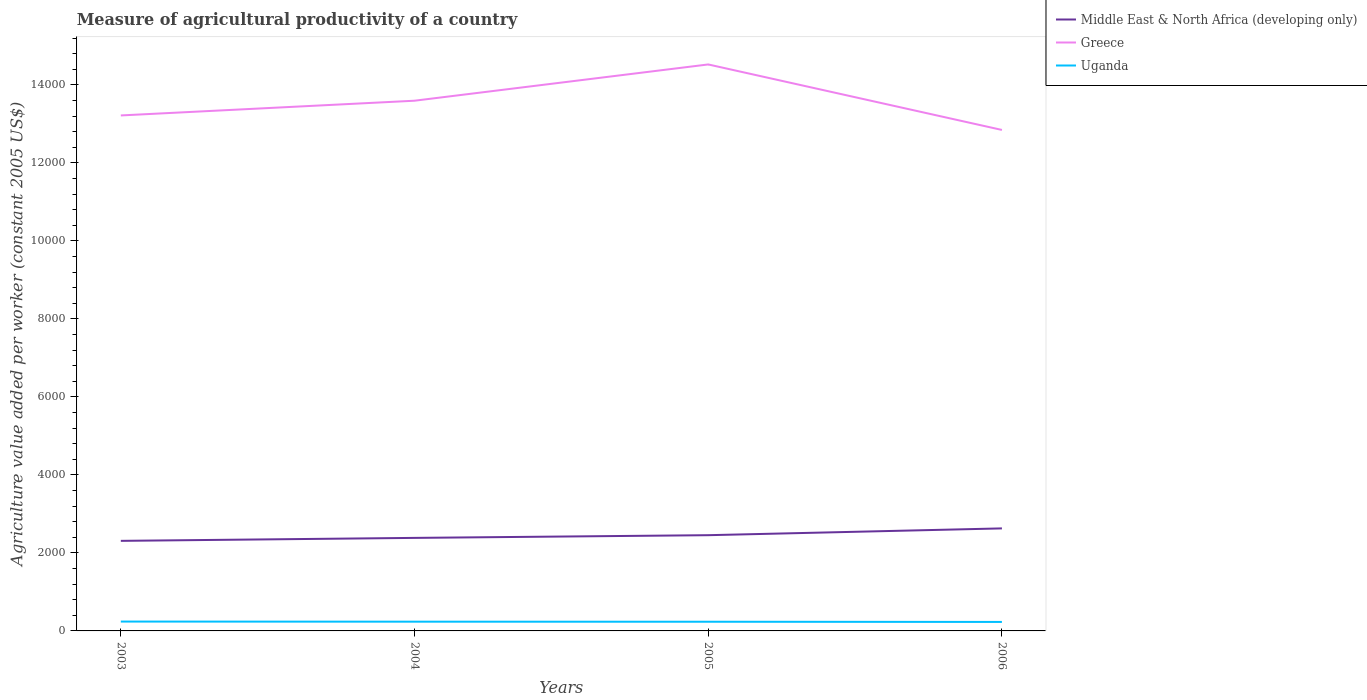Is the number of lines equal to the number of legend labels?
Keep it short and to the point. Yes. Across all years, what is the maximum measure of agricultural productivity in Uganda?
Ensure brevity in your answer.  230.42. What is the total measure of agricultural productivity in Uganda in the graph?
Provide a short and direct response. 1.57. What is the difference between the highest and the second highest measure of agricultural productivity in Uganda?
Keep it short and to the point. 9.42. How many lines are there?
Provide a short and direct response. 3. How many years are there in the graph?
Your answer should be very brief. 4. Are the values on the major ticks of Y-axis written in scientific E-notation?
Keep it short and to the point. No. Does the graph contain any zero values?
Provide a short and direct response. No. Does the graph contain grids?
Your response must be concise. No. Where does the legend appear in the graph?
Keep it short and to the point. Top right. What is the title of the graph?
Offer a very short reply. Measure of agricultural productivity of a country. Does "Italy" appear as one of the legend labels in the graph?
Ensure brevity in your answer.  No. What is the label or title of the Y-axis?
Your answer should be compact. Agriculture value added per worker (constant 2005 US$). What is the Agriculture value added per worker (constant 2005 US$) in Middle East & North Africa (developing only) in 2003?
Provide a succinct answer. 2308.81. What is the Agriculture value added per worker (constant 2005 US$) of Greece in 2003?
Provide a short and direct response. 1.32e+04. What is the Agriculture value added per worker (constant 2005 US$) in Uganda in 2003?
Make the answer very short. 239.84. What is the Agriculture value added per worker (constant 2005 US$) of Middle East & North Africa (developing only) in 2004?
Offer a terse response. 2384.77. What is the Agriculture value added per worker (constant 2005 US$) in Greece in 2004?
Make the answer very short. 1.36e+04. What is the Agriculture value added per worker (constant 2005 US$) of Uganda in 2004?
Ensure brevity in your answer.  237.21. What is the Agriculture value added per worker (constant 2005 US$) in Middle East & North Africa (developing only) in 2005?
Your response must be concise. 2454.17. What is the Agriculture value added per worker (constant 2005 US$) of Greece in 2005?
Provide a short and direct response. 1.45e+04. What is the Agriculture value added per worker (constant 2005 US$) in Uganda in 2005?
Provide a short and direct response. 235.64. What is the Agriculture value added per worker (constant 2005 US$) of Middle East & North Africa (developing only) in 2006?
Ensure brevity in your answer.  2628.31. What is the Agriculture value added per worker (constant 2005 US$) of Greece in 2006?
Offer a terse response. 1.28e+04. What is the Agriculture value added per worker (constant 2005 US$) in Uganda in 2006?
Offer a very short reply. 230.42. Across all years, what is the maximum Agriculture value added per worker (constant 2005 US$) in Middle East & North Africa (developing only)?
Make the answer very short. 2628.31. Across all years, what is the maximum Agriculture value added per worker (constant 2005 US$) of Greece?
Make the answer very short. 1.45e+04. Across all years, what is the maximum Agriculture value added per worker (constant 2005 US$) in Uganda?
Your answer should be very brief. 239.84. Across all years, what is the minimum Agriculture value added per worker (constant 2005 US$) of Middle East & North Africa (developing only)?
Keep it short and to the point. 2308.81. Across all years, what is the minimum Agriculture value added per worker (constant 2005 US$) in Greece?
Your answer should be very brief. 1.28e+04. Across all years, what is the minimum Agriculture value added per worker (constant 2005 US$) in Uganda?
Offer a terse response. 230.42. What is the total Agriculture value added per worker (constant 2005 US$) in Middle East & North Africa (developing only) in the graph?
Keep it short and to the point. 9776.05. What is the total Agriculture value added per worker (constant 2005 US$) in Greece in the graph?
Give a very brief answer. 5.42e+04. What is the total Agriculture value added per worker (constant 2005 US$) of Uganda in the graph?
Keep it short and to the point. 943.11. What is the difference between the Agriculture value added per worker (constant 2005 US$) of Middle East & North Africa (developing only) in 2003 and that in 2004?
Offer a terse response. -75.96. What is the difference between the Agriculture value added per worker (constant 2005 US$) in Greece in 2003 and that in 2004?
Your answer should be compact. -377.48. What is the difference between the Agriculture value added per worker (constant 2005 US$) in Uganda in 2003 and that in 2004?
Offer a very short reply. 2.64. What is the difference between the Agriculture value added per worker (constant 2005 US$) of Middle East & North Africa (developing only) in 2003 and that in 2005?
Your answer should be very brief. -145.36. What is the difference between the Agriculture value added per worker (constant 2005 US$) in Greece in 2003 and that in 2005?
Ensure brevity in your answer.  -1307.27. What is the difference between the Agriculture value added per worker (constant 2005 US$) in Uganda in 2003 and that in 2005?
Ensure brevity in your answer.  4.21. What is the difference between the Agriculture value added per worker (constant 2005 US$) in Middle East & North Africa (developing only) in 2003 and that in 2006?
Your answer should be compact. -319.51. What is the difference between the Agriculture value added per worker (constant 2005 US$) of Greece in 2003 and that in 2006?
Your answer should be very brief. 371.91. What is the difference between the Agriculture value added per worker (constant 2005 US$) in Uganda in 2003 and that in 2006?
Make the answer very short. 9.42. What is the difference between the Agriculture value added per worker (constant 2005 US$) in Middle East & North Africa (developing only) in 2004 and that in 2005?
Offer a terse response. -69.4. What is the difference between the Agriculture value added per worker (constant 2005 US$) in Greece in 2004 and that in 2005?
Your response must be concise. -929.79. What is the difference between the Agriculture value added per worker (constant 2005 US$) of Uganda in 2004 and that in 2005?
Your response must be concise. 1.57. What is the difference between the Agriculture value added per worker (constant 2005 US$) of Middle East & North Africa (developing only) in 2004 and that in 2006?
Offer a terse response. -243.55. What is the difference between the Agriculture value added per worker (constant 2005 US$) of Greece in 2004 and that in 2006?
Give a very brief answer. 749.4. What is the difference between the Agriculture value added per worker (constant 2005 US$) of Uganda in 2004 and that in 2006?
Keep it short and to the point. 6.79. What is the difference between the Agriculture value added per worker (constant 2005 US$) in Middle East & North Africa (developing only) in 2005 and that in 2006?
Provide a succinct answer. -174.15. What is the difference between the Agriculture value added per worker (constant 2005 US$) in Greece in 2005 and that in 2006?
Make the answer very short. 1679.19. What is the difference between the Agriculture value added per worker (constant 2005 US$) of Uganda in 2005 and that in 2006?
Your answer should be very brief. 5.21. What is the difference between the Agriculture value added per worker (constant 2005 US$) of Middle East & North Africa (developing only) in 2003 and the Agriculture value added per worker (constant 2005 US$) of Greece in 2004?
Your answer should be compact. -1.13e+04. What is the difference between the Agriculture value added per worker (constant 2005 US$) in Middle East & North Africa (developing only) in 2003 and the Agriculture value added per worker (constant 2005 US$) in Uganda in 2004?
Your answer should be compact. 2071.6. What is the difference between the Agriculture value added per worker (constant 2005 US$) in Greece in 2003 and the Agriculture value added per worker (constant 2005 US$) in Uganda in 2004?
Your answer should be very brief. 1.30e+04. What is the difference between the Agriculture value added per worker (constant 2005 US$) in Middle East & North Africa (developing only) in 2003 and the Agriculture value added per worker (constant 2005 US$) in Greece in 2005?
Give a very brief answer. -1.22e+04. What is the difference between the Agriculture value added per worker (constant 2005 US$) in Middle East & North Africa (developing only) in 2003 and the Agriculture value added per worker (constant 2005 US$) in Uganda in 2005?
Give a very brief answer. 2073.17. What is the difference between the Agriculture value added per worker (constant 2005 US$) of Greece in 2003 and the Agriculture value added per worker (constant 2005 US$) of Uganda in 2005?
Your response must be concise. 1.30e+04. What is the difference between the Agriculture value added per worker (constant 2005 US$) of Middle East & North Africa (developing only) in 2003 and the Agriculture value added per worker (constant 2005 US$) of Greece in 2006?
Offer a very short reply. -1.05e+04. What is the difference between the Agriculture value added per worker (constant 2005 US$) in Middle East & North Africa (developing only) in 2003 and the Agriculture value added per worker (constant 2005 US$) in Uganda in 2006?
Your response must be concise. 2078.38. What is the difference between the Agriculture value added per worker (constant 2005 US$) in Greece in 2003 and the Agriculture value added per worker (constant 2005 US$) in Uganda in 2006?
Your response must be concise. 1.30e+04. What is the difference between the Agriculture value added per worker (constant 2005 US$) of Middle East & North Africa (developing only) in 2004 and the Agriculture value added per worker (constant 2005 US$) of Greece in 2005?
Provide a short and direct response. -1.21e+04. What is the difference between the Agriculture value added per worker (constant 2005 US$) in Middle East & North Africa (developing only) in 2004 and the Agriculture value added per worker (constant 2005 US$) in Uganda in 2005?
Offer a terse response. 2149.13. What is the difference between the Agriculture value added per worker (constant 2005 US$) in Greece in 2004 and the Agriculture value added per worker (constant 2005 US$) in Uganda in 2005?
Your answer should be compact. 1.34e+04. What is the difference between the Agriculture value added per worker (constant 2005 US$) in Middle East & North Africa (developing only) in 2004 and the Agriculture value added per worker (constant 2005 US$) in Greece in 2006?
Keep it short and to the point. -1.05e+04. What is the difference between the Agriculture value added per worker (constant 2005 US$) of Middle East & North Africa (developing only) in 2004 and the Agriculture value added per worker (constant 2005 US$) of Uganda in 2006?
Give a very brief answer. 2154.34. What is the difference between the Agriculture value added per worker (constant 2005 US$) of Greece in 2004 and the Agriculture value added per worker (constant 2005 US$) of Uganda in 2006?
Your answer should be very brief. 1.34e+04. What is the difference between the Agriculture value added per worker (constant 2005 US$) of Middle East & North Africa (developing only) in 2005 and the Agriculture value added per worker (constant 2005 US$) of Greece in 2006?
Your response must be concise. -1.04e+04. What is the difference between the Agriculture value added per worker (constant 2005 US$) in Middle East & North Africa (developing only) in 2005 and the Agriculture value added per worker (constant 2005 US$) in Uganda in 2006?
Ensure brevity in your answer.  2223.74. What is the difference between the Agriculture value added per worker (constant 2005 US$) of Greece in 2005 and the Agriculture value added per worker (constant 2005 US$) of Uganda in 2006?
Provide a short and direct response. 1.43e+04. What is the average Agriculture value added per worker (constant 2005 US$) in Middle East & North Africa (developing only) per year?
Offer a terse response. 2444.01. What is the average Agriculture value added per worker (constant 2005 US$) of Greece per year?
Provide a succinct answer. 1.35e+04. What is the average Agriculture value added per worker (constant 2005 US$) of Uganda per year?
Keep it short and to the point. 235.78. In the year 2003, what is the difference between the Agriculture value added per worker (constant 2005 US$) of Middle East & North Africa (developing only) and Agriculture value added per worker (constant 2005 US$) of Greece?
Ensure brevity in your answer.  -1.09e+04. In the year 2003, what is the difference between the Agriculture value added per worker (constant 2005 US$) of Middle East & North Africa (developing only) and Agriculture value added per worker (constant 2005 US$) of Uganda?
Keep it short and to the point. 2068.96. In the year 2003, what is the difference between the Agriculture value added per worker (constant 2005 US$) in Greece and Agriculture value added per worker (constant 2005 US$) in Uganda?
Your answer should be compact. 1.30e+04. In the year 2004, what is the difference between the Agriculture value added per worker (constant 2005 US$) in Middle East & North Africa (developing only) and Agriculture value added per worker (constant 2005 US$) in Greece?
Make the answer very short. -1.12e+04. In the year 2004, what is the difference between the Agriculture value added per worker (constant 2005 US$) of Middle East & North Africa (developing only) and Agriculture value added per worker (constant 2005 US$) of Uganda?
Your answer should be very brief. 2147.56. In the year 2004, what is the difference between the Agriculture value added per worker (constant 2005 US$) of Greece and Agriculture value added per worker (constant 2005 US$) of Uganda?
Your response must be concise. 1.34e+04. In the year 2005, what is the difference between the Agriculture value added per worker (constant 2005 US$) in Middle East & North Africa (developing only) and Agriculture value added per worker (constant 2005 US$) in Greece?
Ensure brevity in your answer.  -1.21e+04. In the year 2005, what is the difference between the Agriculture value added per worker (constant 2005 US$) of Middle East & North Africa (developing only) and Agriculture value added per worker (constant 2005 US$) of Uganda?
Your response must be concise. 2218.53. In the year 2005, what is the difference between the Agriculture value added per worker (constant 2005 US$) of Greece and Agriculture value added per worker (constant 2005 US$) of Uganda?
Offer a very short reply. 1.43e+04. In the year 2006, what is the difference between the Agriculture value added per worker (constant 2005 US$) of Middle East & North Africa (developing only) and Agriculture value added per worker (constant 2005 US$) of Greece?
Your response must be concise. -1.02e+04. In the year 2006, what is the difference between the Agriculture value added per worker (constant 2005 US$) in Middle East & North Africa (developing only) and Agriculture value added per worker (constant 2005 US$) in Uganda?
Provide a succinct answer. 2397.89. In the year 2006, what is the difference between the Agriculture value added per worker (constant 2005 US$) in Greece and Agriculture value added per worker (constant 2005 US$) in Uganda?
Give a very brief answer. 1.26e+04. What is the ratio of the Agriculture value added per worker (constant 2005 US$) in Middle East & North Africa (developing only) in 2003 to that in 2004?
Your answer should be very brief. 0.97. What is the ratio of the Agriculture value added per worker (constant 2005 US$) in Greece in 2003 to that in 2004?
Offer a terse response. 0.97. What is the ratio of the Agriculture value added per worker (constant 2005 US$) in Uganda in 2003 to that in 2004?
Provide a succinct answer. 1.01. What is the ratio of the Agriculture value added per worker (constant 2005 US$) of Middle East & North Africa (developing only) in 2003 to that in 2005?
Keep it short and to the point. 0.94. What is the ratio of the Agriculture value added per worker (constant 2005 US$) in Greece in 2003 to that in 2005?
Ensure brevity in your answer.  0.91. What is the ratio of the Agriculture value added per worker (constant 2005 US$) in Uganda in 2003 to that in 2005?
Make the answer very short. 1.02. What is the ratio of the Agriculture value added per worker (constant 2005 US$) of Middle East & North Africa (developing only) in 2003 to that in 2006?
Your answer should be very brief. 0.88. What is the ratio of the Agriculture value added per worker (constant 2005 US$) in Uganda in 2003 to that in 2006?
Keep it short and to the point. 1.04. What is the ratio of the Agriculture value added per worker (constant 2005 US$) in Middle East & North Africa (developing only) in 2004 to that in 2005?
Offer a terse response. 0.97. What is the ratio of the Agriculture value added per worker (constant 2005 US$) in Greece in 2004 to that in 2005?
Give a very brief answer. 0.94. What is the ratio of the Agriculture value added per worker (constant 2005 US$) of Middle East & North Africa (developing only) in 2004 to that in 2006?
Ensure brevity in your answer.  0.91. What is the ratio of the Agriculture value added per worker (constant 2005 US$) in Greece in 2004 to that in 2006?
Your answer should be compact. 1.06. What is the ratio of the Agriculture value added per worker (constant 2005 US$) in Uganda in 2004 to that in 2006?
Make the answer very short. 1.03. What is the ratio of the Agriculture value added per worker (constant 2005 US$) of Middle East & North Africa (developing only) in 2005 to that in 2006?
Your answer should be compact. 0.93. What is the ratio of the Agriculture value added per worker (constant 2005 US$) of Greece in 2005 to that in 2006?
Your response must be concise. 1.13. What is the ratio of the Agriculture value added per worker (constant 2005 US$) of Uganda in 2005 to that in 2006?
Keep it short and to the point. 1.02. What is the difference between the highest and the second highest Agriculture value added per worker (constant 2005 US$) of Middle East & North Africa (developing only)?
Your answer should be compact. 174.15. What is the difference between the highest and the second highest Agriculture value added per worker (constant 2005 US$) of Greece?
Provide a succinct answer. 929.79. What is the difference between the highest and the second highest Agriculture value added per worker (constant 2005 US$) of Uganda?
Keep it short and to the point. 2.64. What is the difference between the highest and the lowest Agriculture value added per worker (constant 2005 US$) of Middle East & North Africa (developing only)?
Give a very brief answer. 319.51. What is the difference between the highest and the lowest Agriculture value added per worker (constant 2005 US$) of Greece?
Your answer should be very brief. 1679.19. What is the difference between the highest and the lowest Agriculture value added per worker (constant 2005 US$) in Uganda?
Make the answer very short. 9.42. 